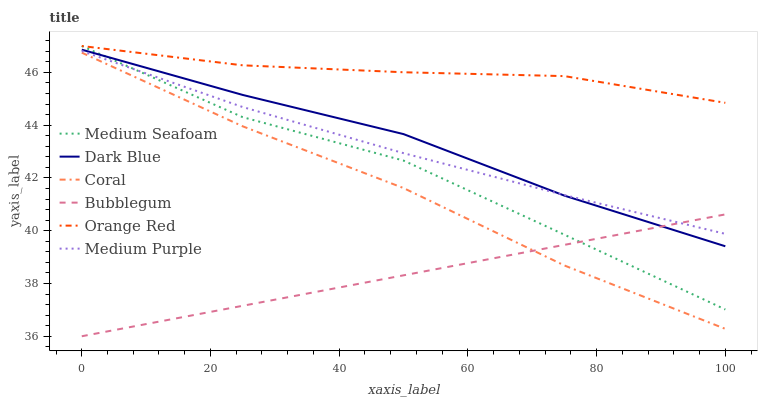Does Orange Red have the minimum area under the curve?
Answer yes or no. No. Does Bubblegum have the maximum area under the curve?
Answer yes or no. No. Is Orange Red the smoothest?
Answer yes or no. No. Is Orange Red the roughest?
Answer yes or no. No. Does Orange Red have the lowest value?
Answer yes or no. No. Does Bubblegum have the highest value?
Answer yes or no. No. Is Coral less than Medium Seafoam?
Answer yes or no. Yes. Is Orange Red greater than Coral?
Answer yes or no. Yes. Does Coral intersect Medium Seafoam?
Answer yes or no. No. 